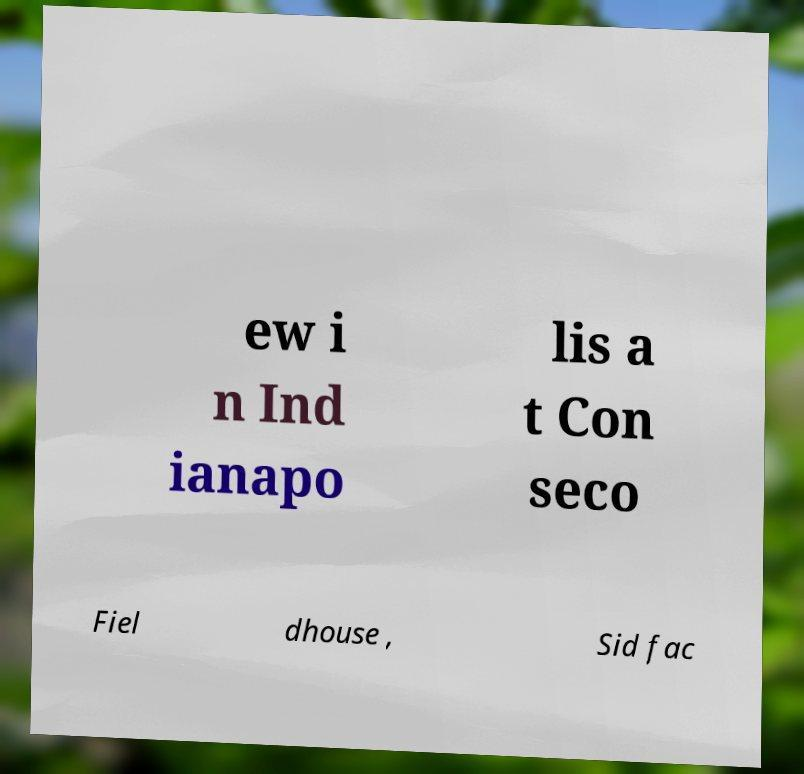Please identify and transcribe the text found in this image. ew i n Ind ianapo lis a t Con seco Fiel dhouse , Sid fac 